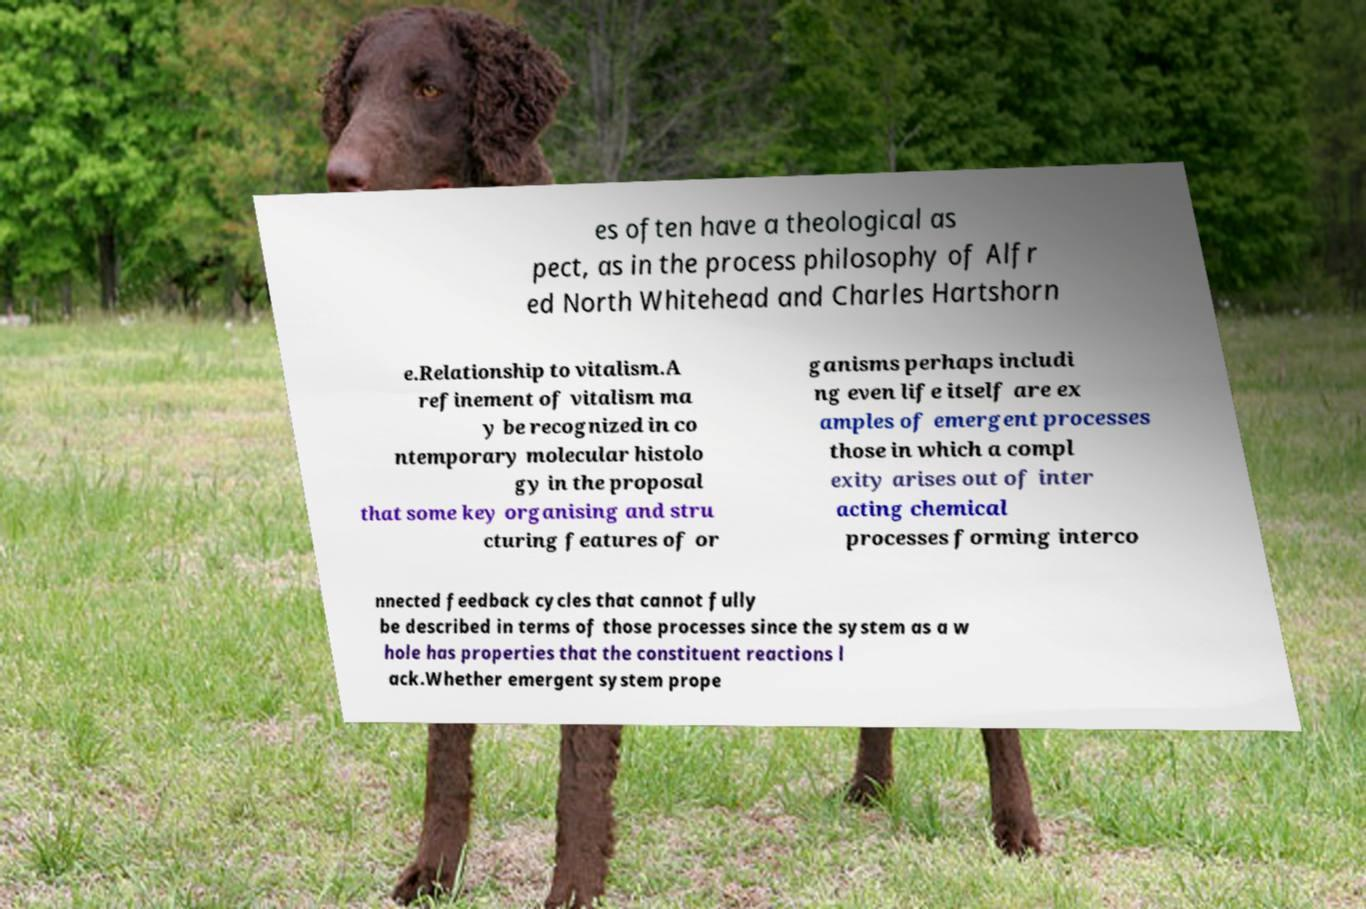There's text embedded in this image that I need extracted. Can you transcribe it verbatim? es often have a theological as pect, as in the process philosophy of Alfr ed North Whitehead and Charles Hartshorn e.Relationship to vitalism.A refinement of vitalism ma y be recognized in co ntemporary molecular histolo gy in the proposal that some key organising and stru cturing features of or ganisms perhaps includi ng even life itself are ex amples of emergent processes those in which a compl exity arises out of inter acting chemical processes forming interco nnected feedback cycles that cannot fully be described in terms of those processes since the system as a w hole has properties that the constituent reactions l ack.Whether emergent system prope 